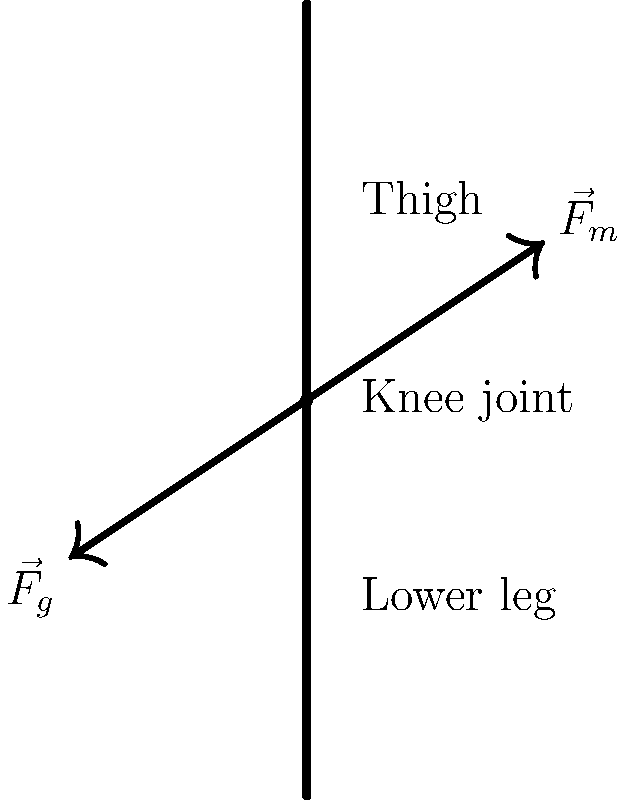In the diagram of a human knee joint during movement, two forces are shown: $\vec{F}_m$ representing the muscle force and $\vec{F}_g$ representing the gravitational force. If $\vec{F}_m$ has a magnitude of 500 N and makes an angle of 30° with the vertical, while $\vec{F}_g$ has a magnitude of 300 N and makes an angle of 150° with the vertical, calculate the magnitude of the net force acting on the knee joint. To solve this problem, we need to follow these steps:

1. Decompose each force into its x and y components:

   For $\vec{F}_m$:
   $F_{mx} = 500 \cdot \sin(30°) = 250$ N
   $F_{my} = 500 \cdot \cos(30°) = 433.01$ N

   For $\vec{F}_g$:
   $F_{gx} = 300 \cdot \sin(150°) = 150$ N
   $F_{gy} = -300 \cdot \cos(150°) = 259.81$ N

2. Sum the x and y components separately:

   $F_x = F_{mx} + F_{gx} = 250 + 150 = 400$ N
   $F_y = F_{my} + F_{gy} = 433.01 + 259.81 = 692.82$ N

3. Calculate the magnitude of the resultant force using the Pythagorean theorem:

   $F_{net} = \sqrt{F_x^2 + F_y^2} = \sqrt{400^2 + 692.82^2} = 799.96$ N

Therefore, the magnitude of the net force acting on the knee joint is approximately 800 N.
Answer: 800 N 